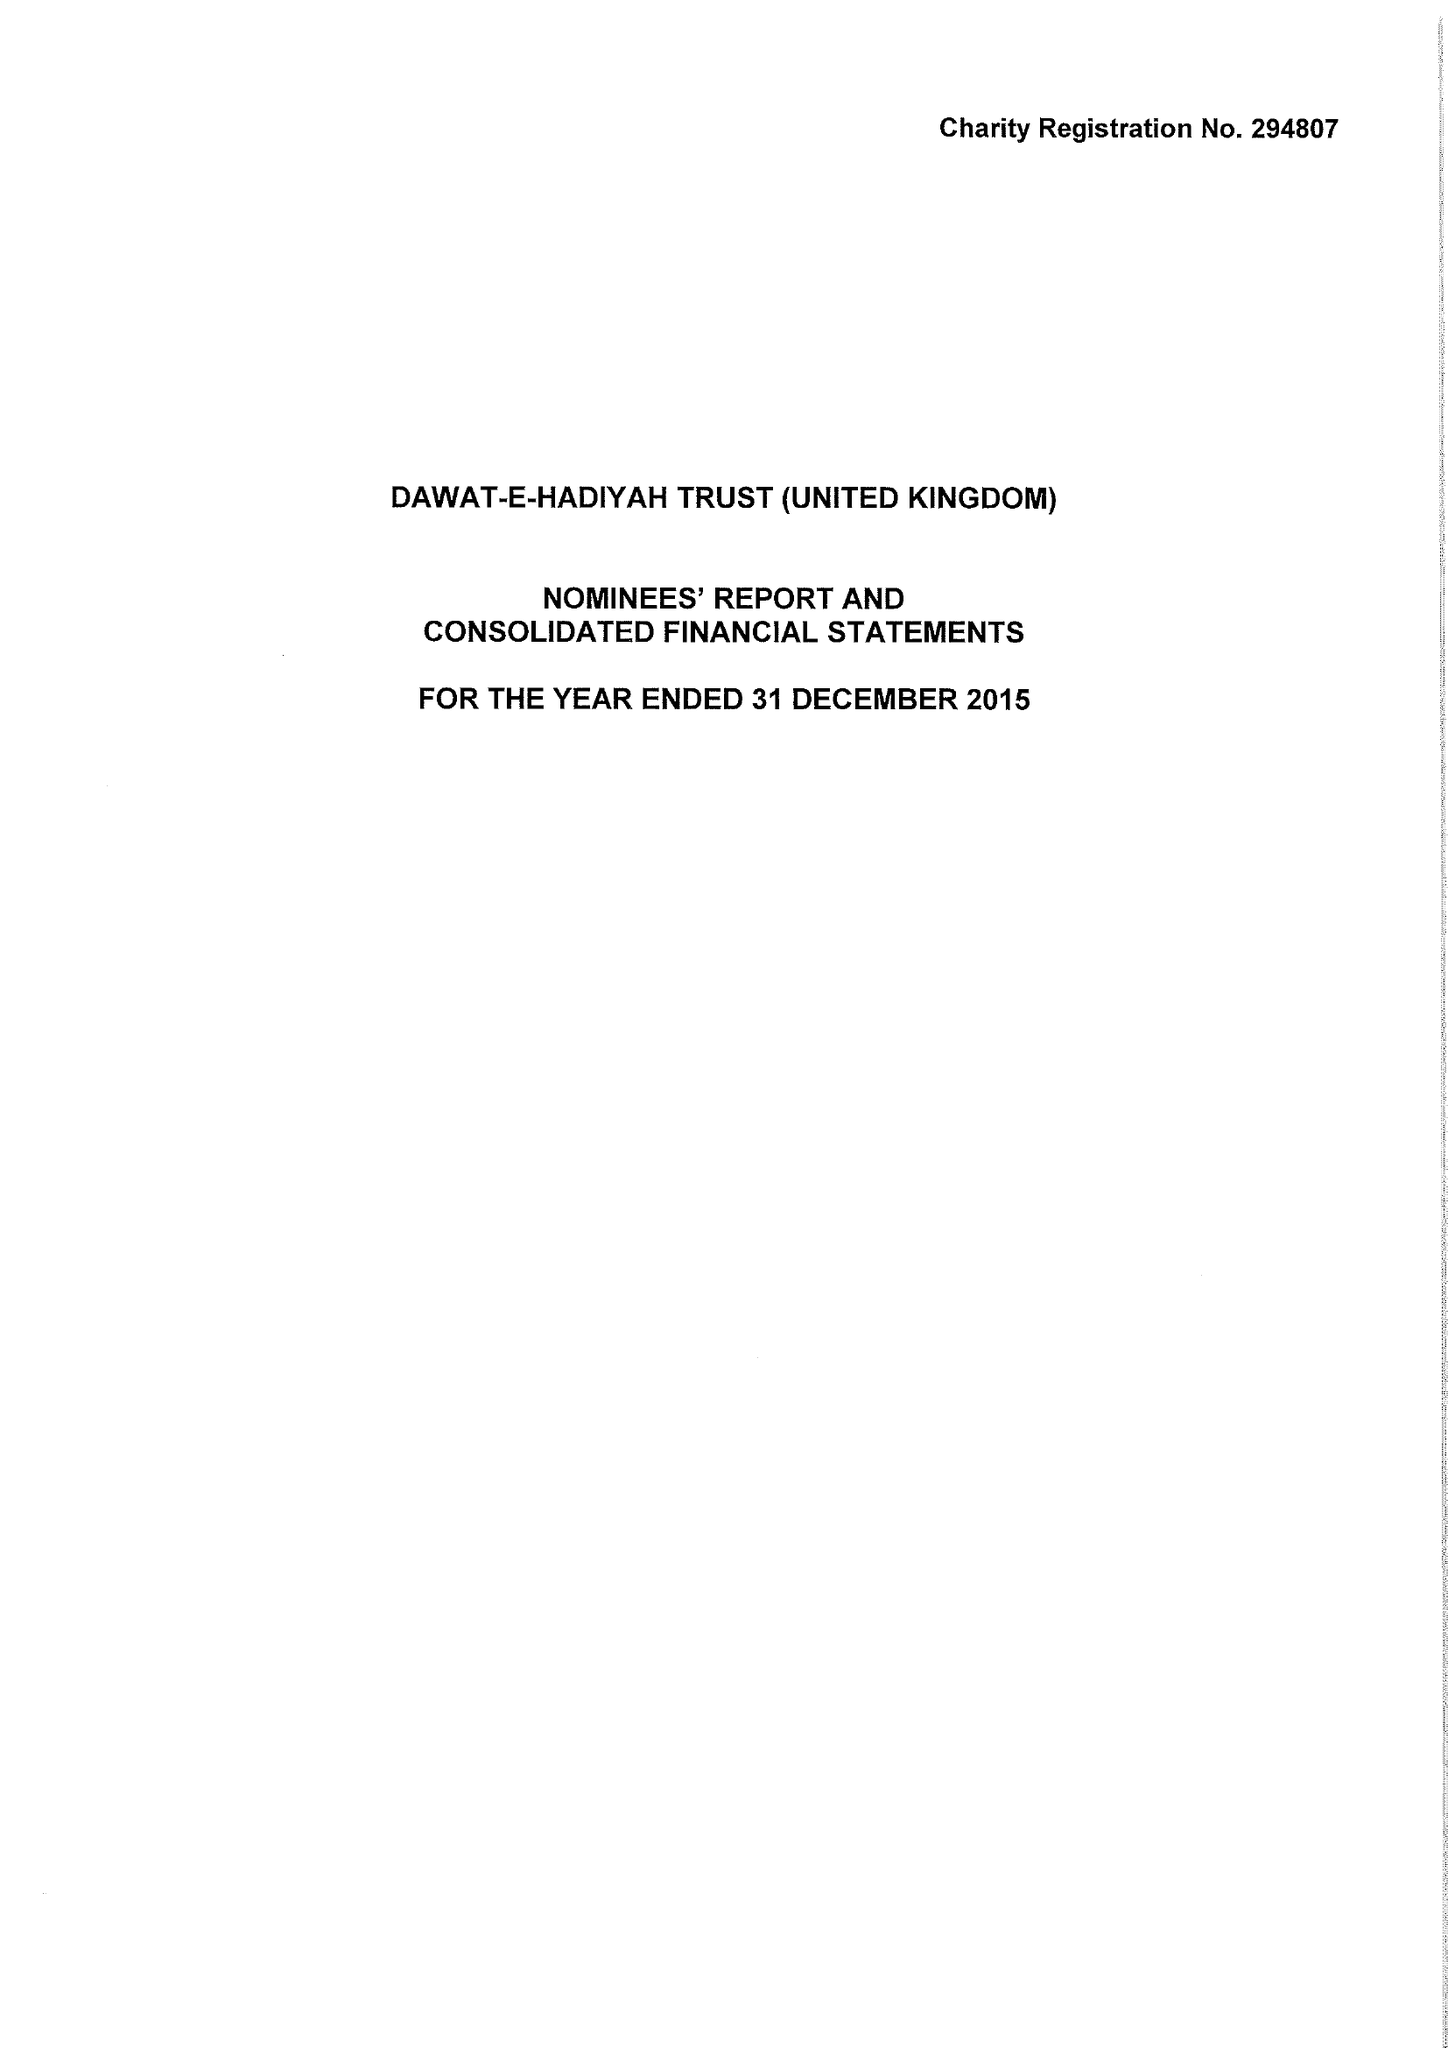What is the value for the charity_name?
Answer the question using a single word or phrase. Dawat-E-Hadiyah Trust (United Kingdom) 